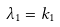<formula> <loc_0><loc_0><loc_500><loc_500>\lambda _ { 1 } = k _ { 1 }</formula> 